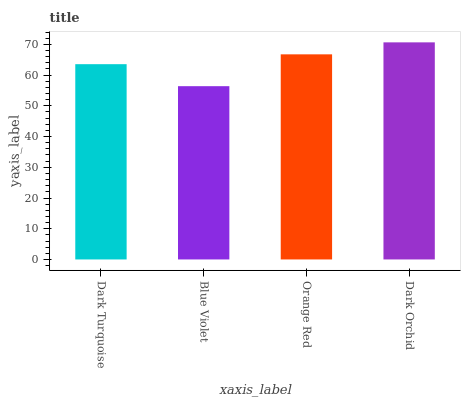Is Blue Violet the minimum?
Answer yes or no. Yes. Is Dark Orchid the maximum?
Answer yes or no. Yes. Is Orange Red the minimum?
Answer yes or no. No. Is Orange Red the maximum?
Answer yes or no. No. Is Orange Red greater than Blue Violet?
Answer yes or no. Yes. Is Blue Violet less than Orange Red?
Answer yes or no. Yes. Is Blue Violet greater than Orange Red?
Answer yes or no. No. Is Orange Red less than Blue Violet?
Answer yes or no. No. Is Orange Red the high median?
Answer yes or no. Yes. Is Dark Turquoise the low median?
Answer yes or no. Yes. Is Dark Turquoise the high median?
Answer yes or no. No. Is Dark Orchid the low median?
Answer yes or no. No. 